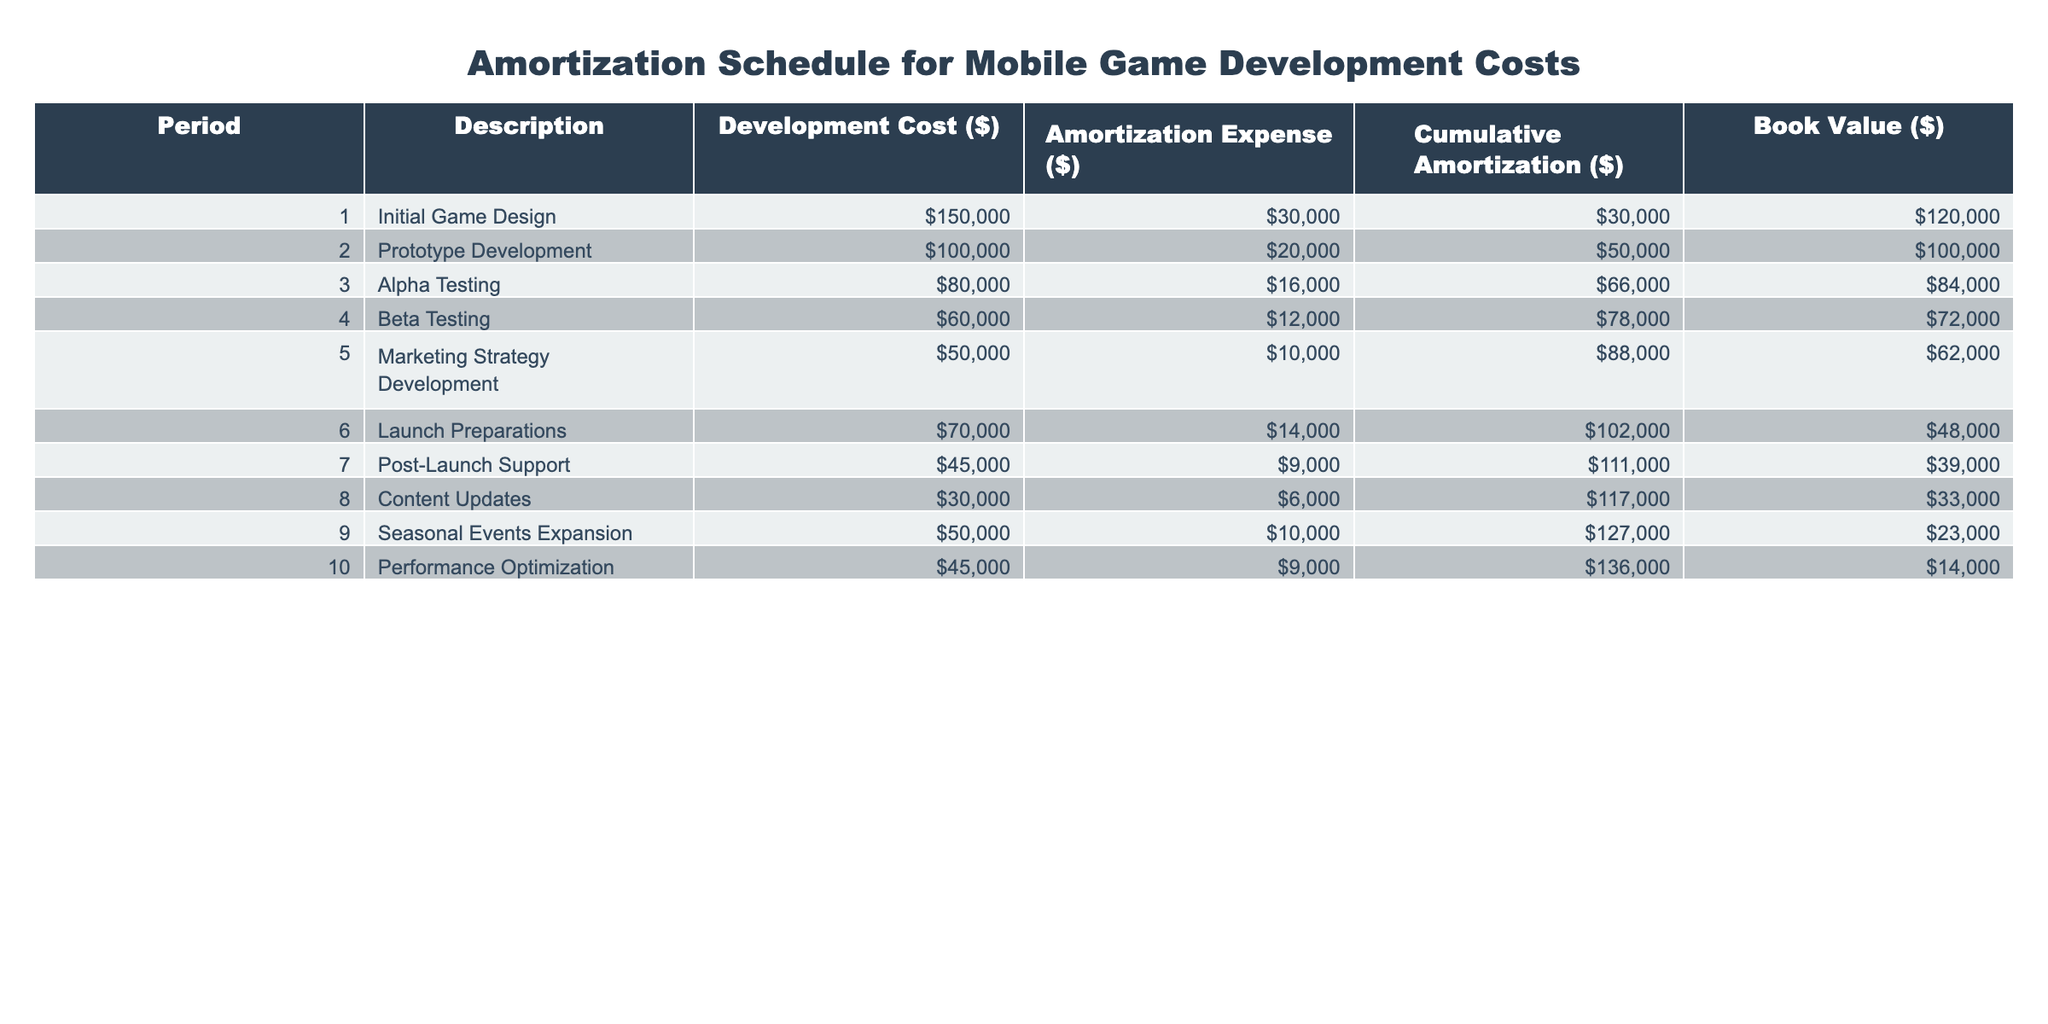What's the total development cost for the initial game design? The table specifies the development cost for the initial game design as 150000 dollars.
Answer: 150000 What is the cumulative amortization after period 6? The cumulative amortization for period 6 is listed in the table as 102000 dollars.
Answer: 102000 How much was the amortization expense for beta testing? The amortization expense allocated for beta testing is indicated in the table as 12000 dollars.
Answer: 12000 What is the book value at the end of period 4? The book value at the end of period 4 is provided in the table as 72000 dollars.
Answer: 72000 What is the total amortization expense from periods 3 to 5? To find the total amortization expense from periods 3 to 5, we add the amounts: 16000 (Alpha Testing) + 12000 (Beta Testing) + 10000 (Marketing Strategy Development) = 38000 dollars.
Answer: 38000 Is the cumulative amortization greater than the book value at period 8? At period 8, the cumulative amortization is 117000 dollars, and the book value is 33000 dollars. Since 117000 is greater than 33000, the statement is true.
Answer: Yes By how much did the book value decrease from period 1 to period 10? The book value in period 1 is 120000 dollars, and in period 10 it is 14000 dollars. The decrease is 120000 - 14000 = 106000 dollars.
Answer: 106000 What is the average amortization expense over the 10 periods? Sum the amortization expenses for all periods: 30000 + 20000 + 16000 + 12000 + 10000 + 14000 + 9000 + 6000 + 10000 + 9000 = 130000 dollars. Then divide by 10 periods, giving an average of 13000 dollars.
Answer: 13000 Is the amortization expense for launch preparations higher than that of prototype development? The table shows the amortization expense for launch preparations as 14000 dollars and for prototype development as 20000 dollars. Since 14000 is less than 20000, the statement is false.
Answer: No 